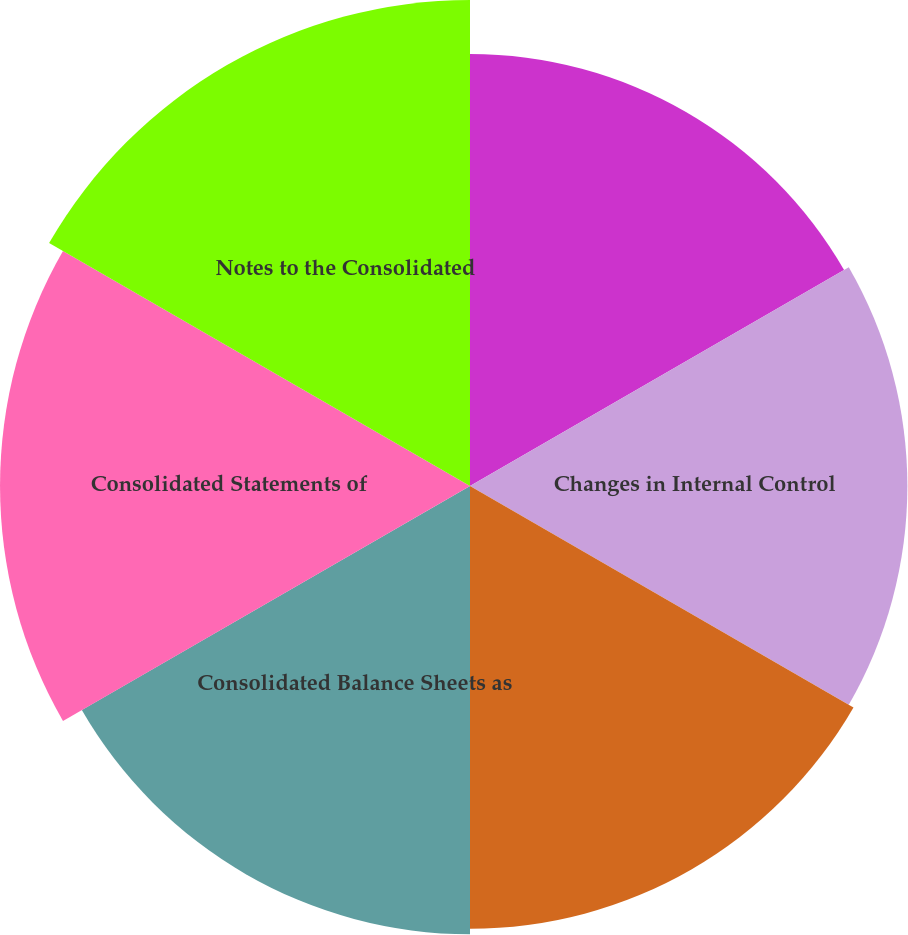Convert chart. <chart><loc_0><loc_0><loc_500><loc_500><pie_chart><fcel>Annual Report of Management on<fcel>Changes in Internal Control<fcel>Report of Independent<fcel>Consolidated Balance Sheets as<fcel>Consolidated Statements of<fcel>Notes to the Consolidated<nl><fcel>15.9%<fcel>16.1%<fcel>16.3%<fcel>16.5%<fcel>17.3%<fcel>17.89%<nl></chart> 